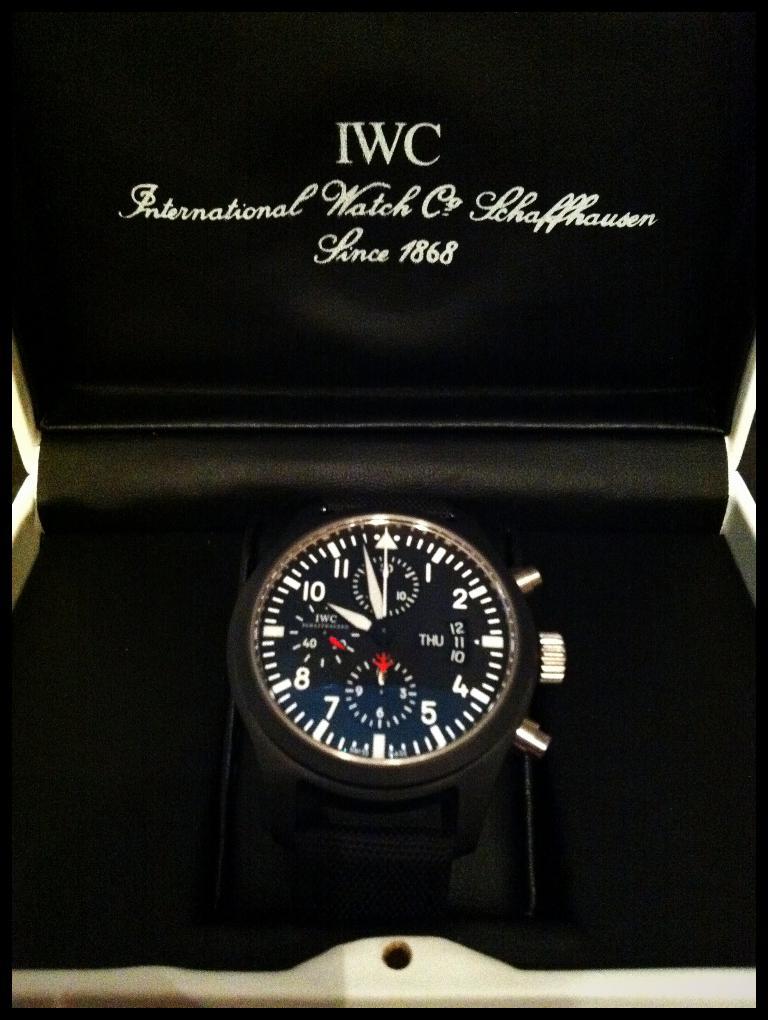What is the brand of watch?
Keep it short and to the point. Iwc. When was this watch brand founded?
Provide a short and direct response. 1868. 